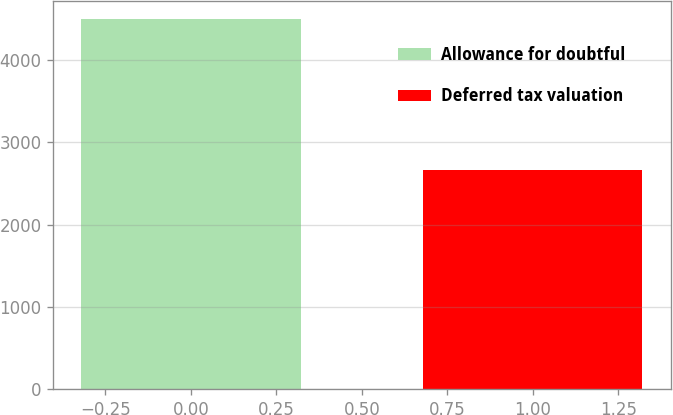Convert chart to OTSL. <chart><loc_0><loc_0><loc_500><loc_500><bar_chart><fcel>Allowance for doubtful<fcel>Deferred tax valuation<nl><fcel>4491<fcel>2660<nl></chart> 